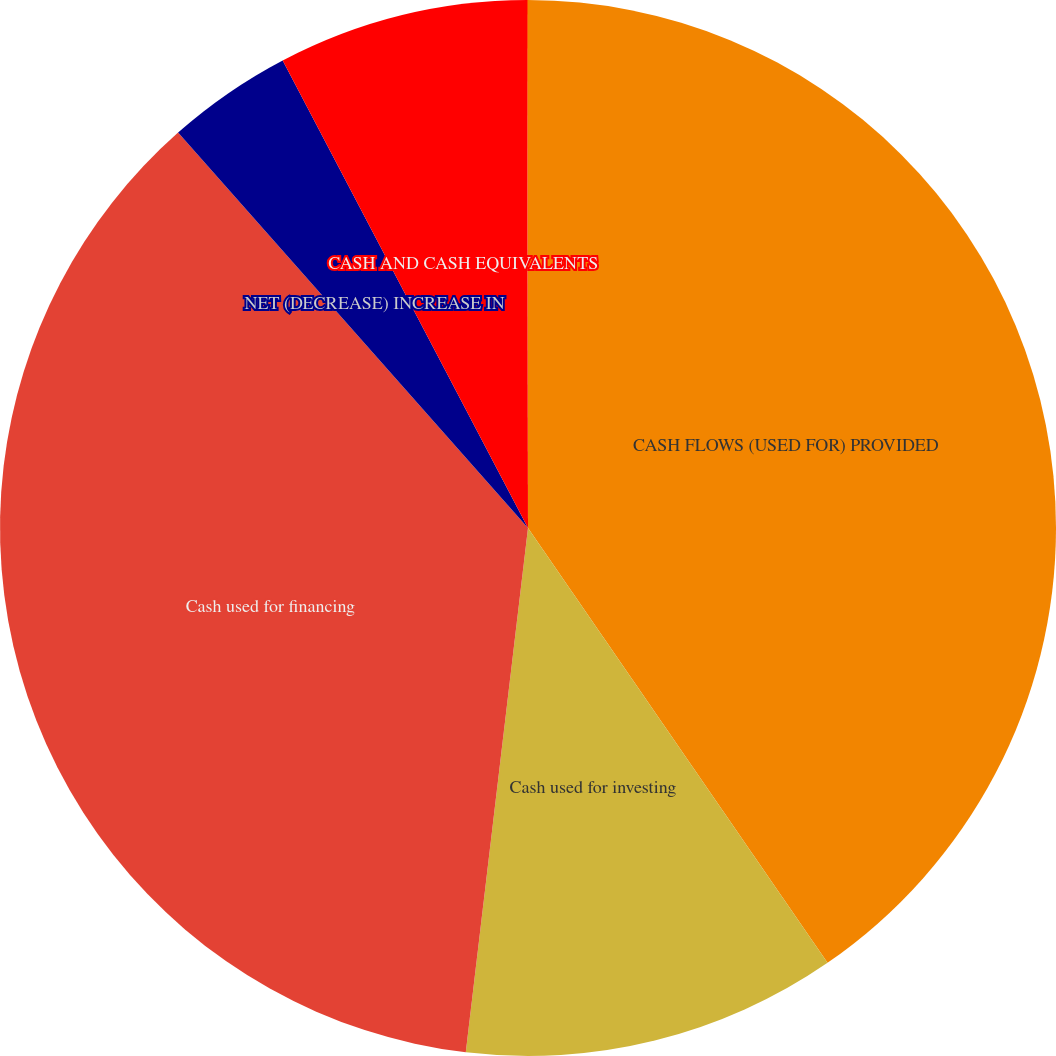Convert chart to OTSL. <chart><loc_0><loc_0><loc_500><loc_500><pie_chart><fcel>CASH FLOWS (USED FOR) PROVIDED<fcel>Cash used for investing<fcel>Cash used for financing<fcel>NET (DECREASE) INCREASE IN<fcel>CASH AND CASH EQUIVALENTS<fcel>CASH AND CASH EQUIVALENTS END<nl><fcel>40.4%<fcel>11.48%<fcel>36.59%<fcel>3.84%<fcel>7.66%<fcel>0.03%<nl></chart> 